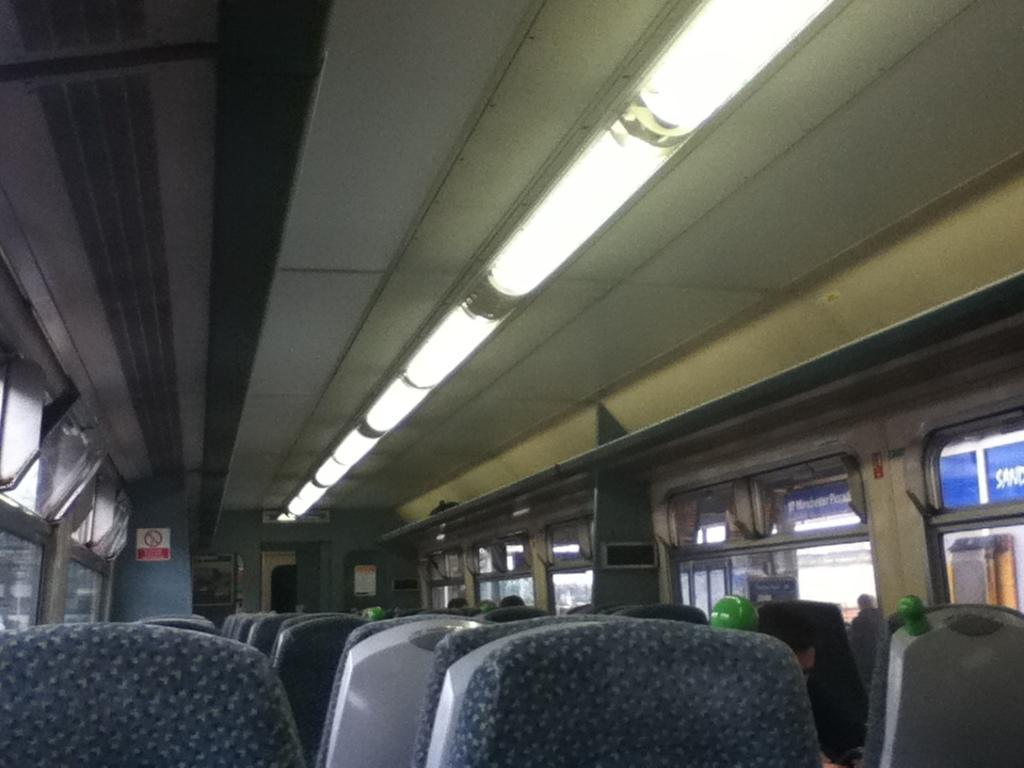Can you describe this image briefly? This picture is taken inside the bus. In this image there are seats one beside the other in the line. At the top there are lights. There are windows on either side of the bus. 